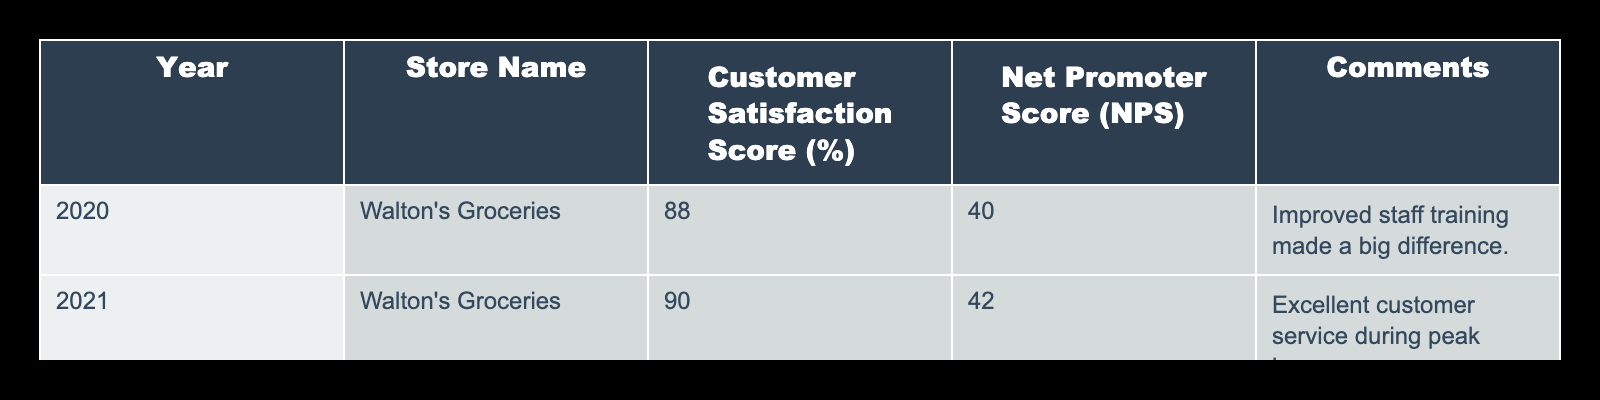What was the customer satisfaction score for 2021? Refer to the row for the year 2021 and find the corresponding score, which is clearly listed in the "Customer Satisfaction Score (%)" column. The score for 2021 is 90.
Answer: 90 What is the Net Promoter Score for Walton's Groceries in 2020? Locate the data for the year 2020 in the table. The Net Promoter Score (NPS) for Walton's Groceries in that year is provided directly in the relevant column, which is 40.
Answer: 40 What year had the highest customer satisfaction score? Compare the scores across all years listed in the table for customer satisfaction. The highest score is found by evaluating the scores: 88 (2020), 90 (2021), and 89 (2023). The highest score is 90 in 2021.
Answer: 2021 What is the average customer satisfaction score over the three years? First, add the customer satisfaction scores: 88 + 90 + 89 = 267. Then, divide the total by the number of years (3) to find the average: 267 / 3 = 89. The average score is 89.
Answer: 89 Did the customer satisfaction score improve from 2020 to 2021? Assess the scores for 2020 and 2021, which are 88 and 90 respectively. Since 90 is greater than 88, this indicates an improvement in customer satisfaction.
Answer: Yes What trend in customer satisfaction can be observed from 2020 to 2023? Examine the customer satisfaction scores for each year: 88 (2020), 90 (2021), and 89 (2023). The scores show an increase from 2020 to 2021, followed by a slight decrease in 2023. This suggests an initial improvement followed by a drop.
Answer: Improvement then slight decrease What comments were provided for the year 2023? Look at the row for the year 2023 to find the corresponding comment. The comment in that row states "Steady improvement in overall customer experience."
Answer: Steady improvement in overall customer experience Is there a year where the Net Promoter Score decreased compared to the previous year? Check the Net Promoter Scores for each consecutive year: 40 (2020), 42 (2021), and 39 (2023). The score dropped from 42 in 2021 to 39 in 2023, indicating a decrease.
Answer: Yes What is the difference in customer satisfaction scores between the years 2021 and 2023? Determine the scores for both years: 90 (2021) and 89 (2023). Subtract the score for 2023 from that of 2021: 90 - 89 = 1. The difference is 1 point.
Answer: 1 